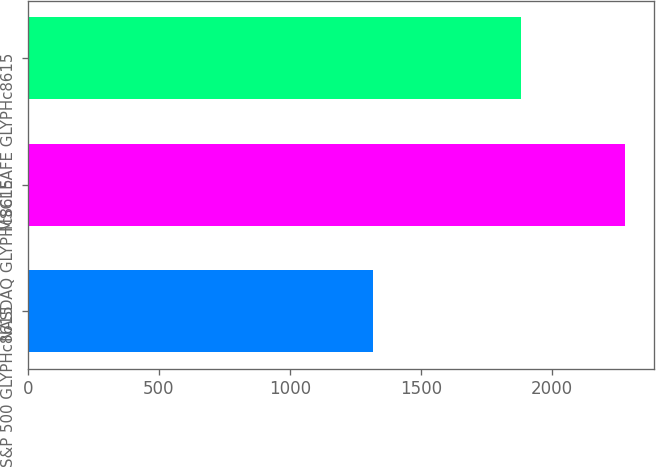<chart> <loc_0><loc_0><loc_500><loc_500><bar_chart><fcel>S&P 500 GLYPHc8615<fcel>NASDAQ GLYPHc8615<fcel>MSCI EAFE GLYPHc8615<nl><fcel>1318<fcel>2279<fcel>1883<nl></chart> 